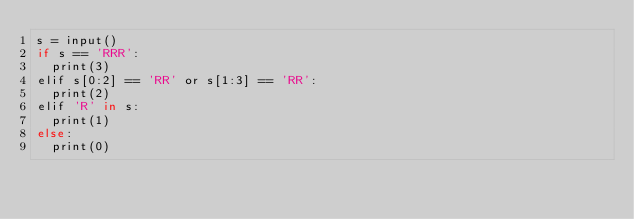<code> <loc_0><loc_0><loc_500><loc_500><_TypeScript_>s = input()
if s == 'RRR':
  print(3)
elif s[0:2] == 'RR' or s[1:3] == 'RR':
  print(2)
elif 'R' in s:
  print(1)
else:
  print(0)</code> 